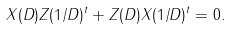Convert formula to latex. <formula><loc_0><loc_0><loc_500><loc_500>X ( D ) Z ( 1 / D ) ^ { t } + Z ( D ) X ( 1 / D ) ^ { t } = 0 .</formula> 